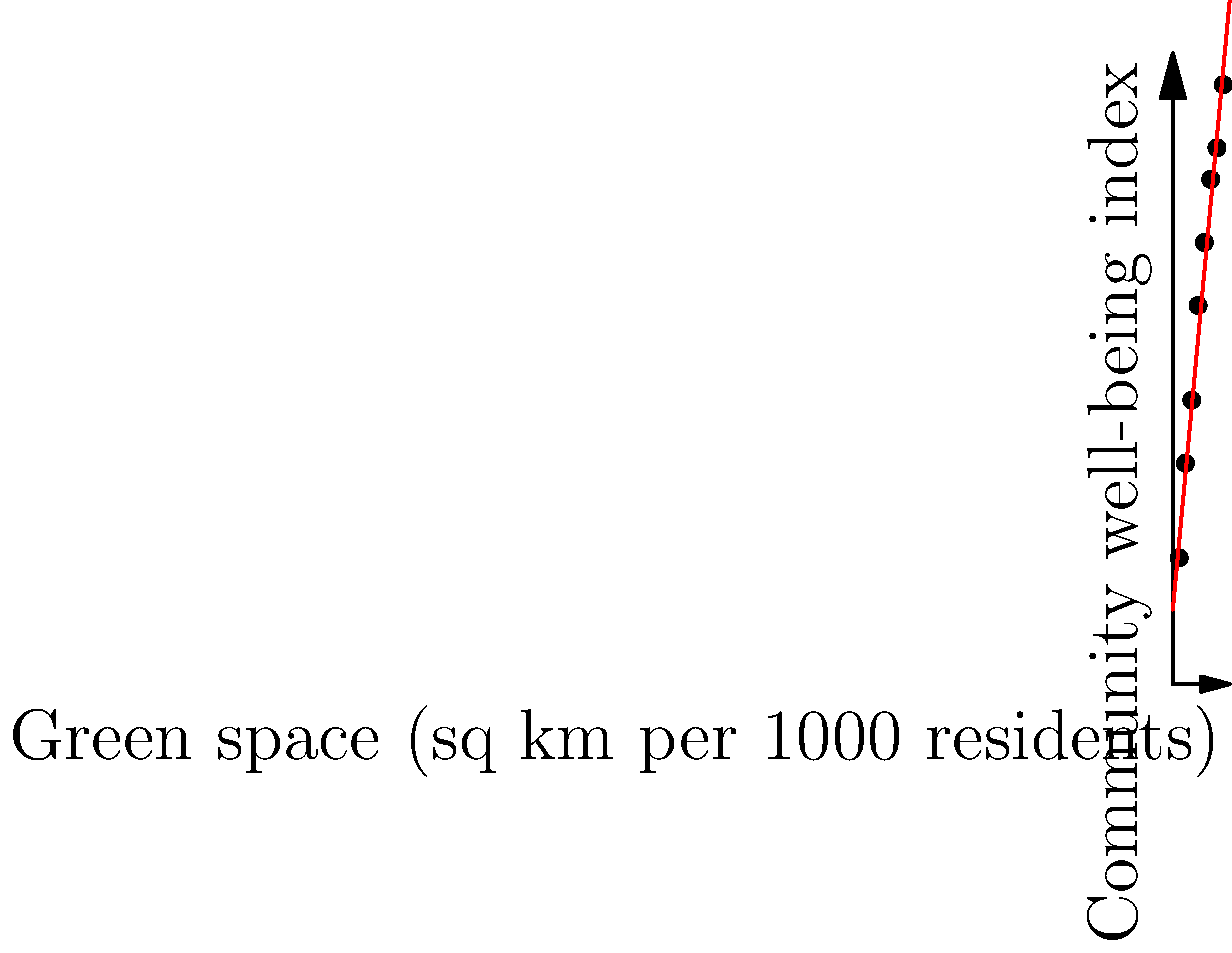Based on the scatter plot showing the relationship between public green spaces and community well-being in various Thai cities, what can be inferred about the correlation between these two variables? How might this information influence community-focused public policy decisions in Thailand? To analyze the correlation between public green spaces and community well-being:

1. Observe the scatter plot: Points show an upward trend from left to right.

2. Identify the variables:
   - X-axis: Green space (sq km per 1000 residents)
   - Y-axis: Community well-being index

3. Analyze the trend:
   - As green space increases, the community well-being index generally increases.
   - The red line represents the best-fit line, showing a positive slope.

4. Interpret the correlation:
   - There is a strong positive correlation between green space and community well-being.
   - The relationship appears to be roughly linear.

5. Calculate the correlation coefficient (not shown, but assumed to be strong based on the plot).

6. Policy implications for Thailand:
   - Investing in public green spaces likely improves community well-being.
   - Urban planning should prioritize creating and maintaining green areas.
   - Policymakers could use this data to justify green space initiatives.
   - Consider setting minimum green space requirements for new developments.

7. Limitations:
   - Correlation does not imply causation; other factors may influence well-being.
   - The sample size (8 data points) is relatively small.

8. Further considerations:
   - Investigate the quality and accessibility of green spaces, not just quantity.
   - Study the distribution of green spaces across different communities.
   - Consider the cost-effectiveness of green space development compared to other well-being initiatives.
Answer: Strong positive correlation; invest in green spaces to improve community well-being. 